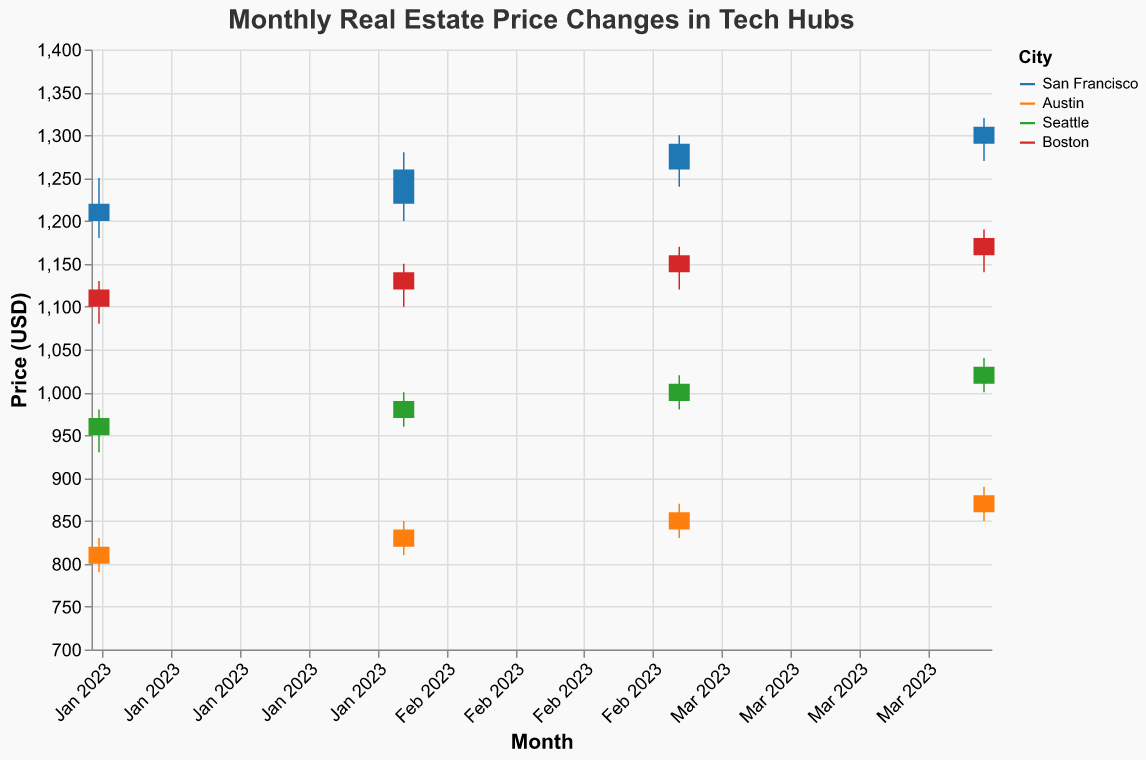What's the title of the chart? The title of the chart can be found at the top of the figure.
Answer: Monthly Real Estate Price Changes in Tech Hubs What are the cities compared in this chart? The cities compared are visible through the legend or by reading the labels associated with the different data series in the chart.
Answer: San Francisco, Austin, Seattle, Boston Which city had the highest price at the end of April 2023? Look at the closing prices for April 2023 and find the maximum among the cities.
Answer: San Francisco What is the price difference between the highest and lowest open prices in Seattle during the 4 months? Identify the highest and lowest open prices in Seattle, then subtract the lowest from the highest.
Answer: 60 (1010 - 950) Which city showed the most consistent monthly increase in closing prices? Evaluate which city has a steady increase in closing prices each month by observing the slope trends for each city's closing prices over the months.
Answer: Austin By how much did the price in Boston increase from January to April 2023? Find the difference between the closing prices of April 2023 and January 2023 for Boston.
Answer: 60 (1180 - 1120) Are there any months where Austin's high and low prices stayed within a smaller range compared to other cities? Compare the vertical distance (range between high and low) of Austin with the other cities for each month to see if there are any months with a noticeably smaller range.
Answer: Yes, January What city had the highest monthly volatility, considering the range between low and high prices in each month? Calculate the range (high - low) for each city each month and identify the city with the greatest ranges.
Answer: San Francisco Which city had the smallest monthly closing price growth from January to April? Determine the difference in closing prices from January to April for each city and find the city with the smallest growth.
Answer: Seattle 